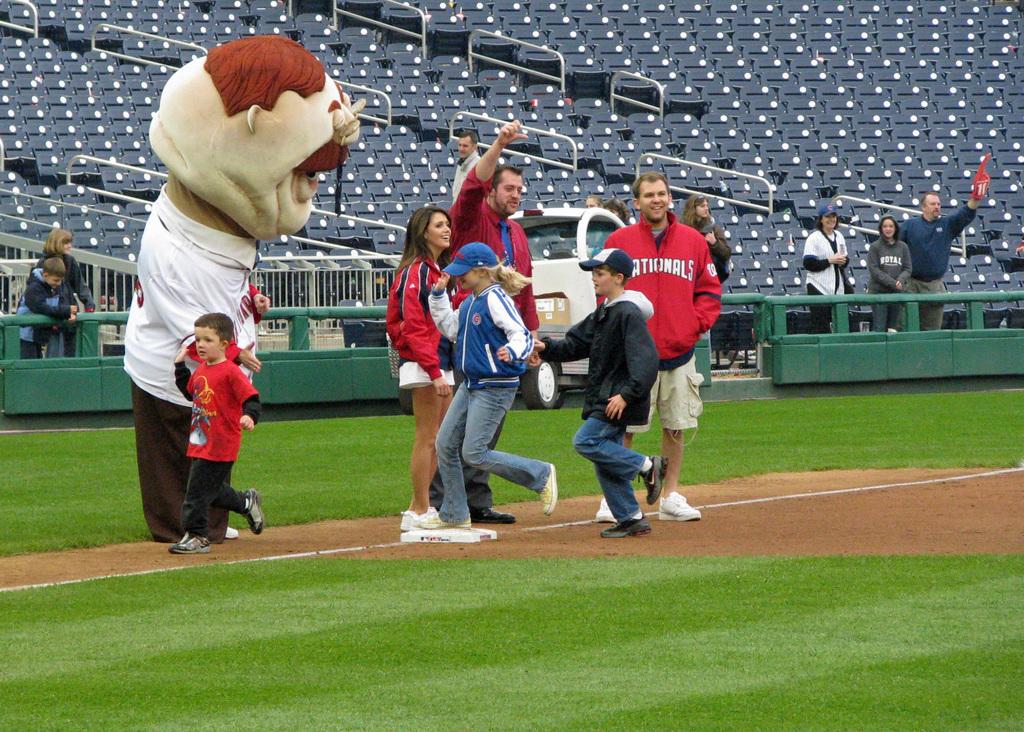Who does the man in the red jacket cheer for in baseball?
Keep it short and to the point. Nationals. 